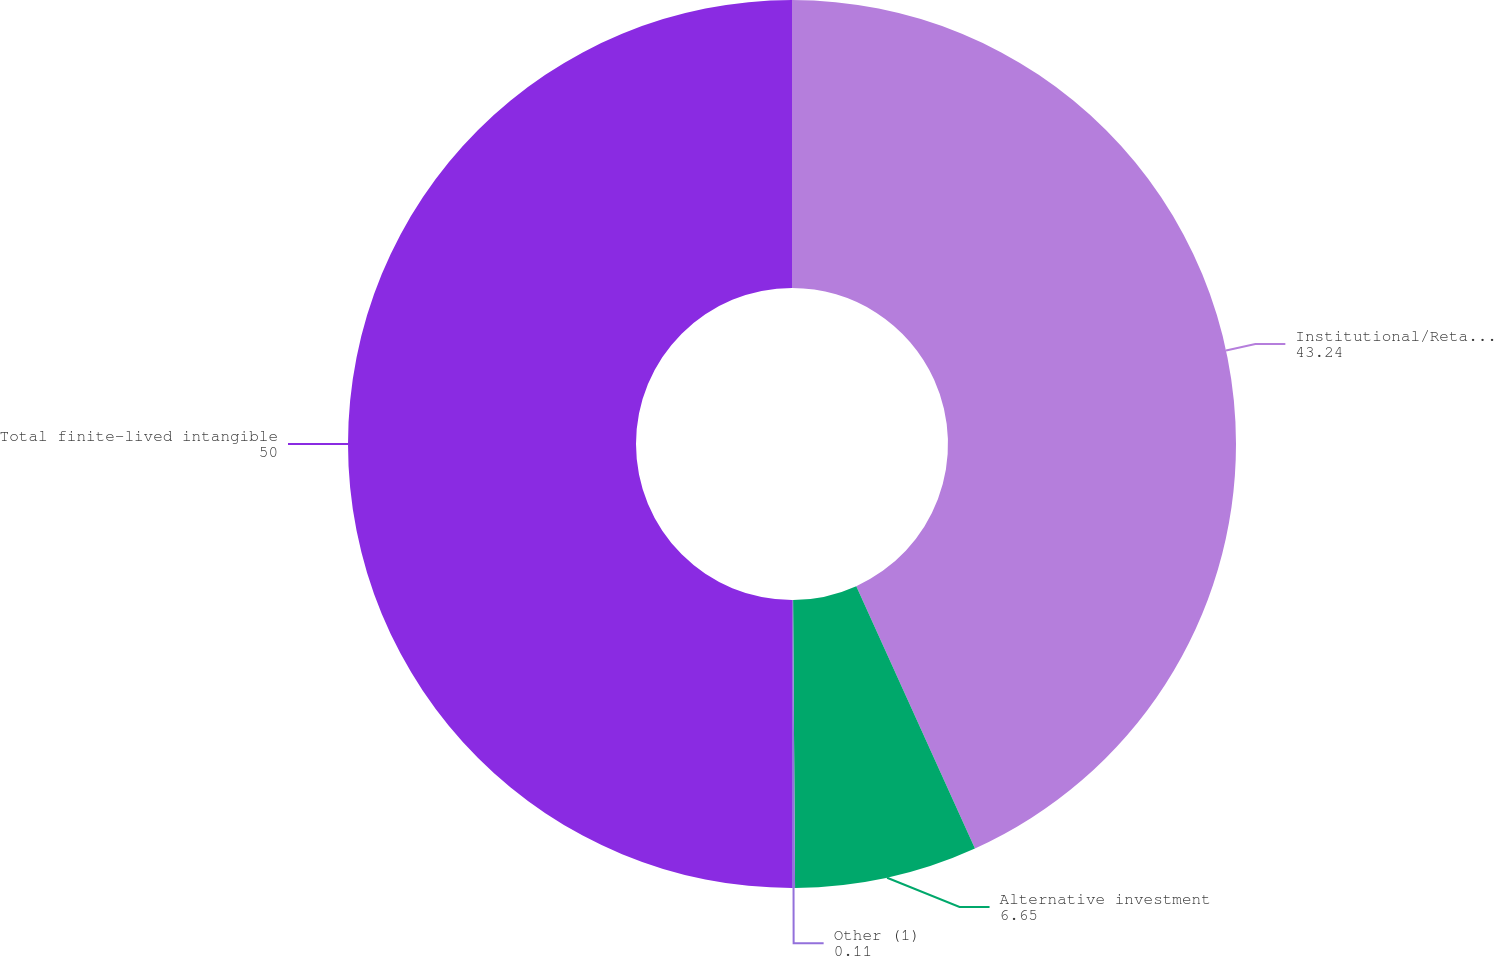<chart> <loc_0><loc_0><loc_500><loc_500><pie_chart><fcel>Institutional/Retail separate<fcel>Alternative investment<fcel>Other (1)<fcel>Total finite-lived intangible<nl><fcel>43.24%<fcel>6.65%<fcel>0.11%<fcel>50.0%<nl></chart> 